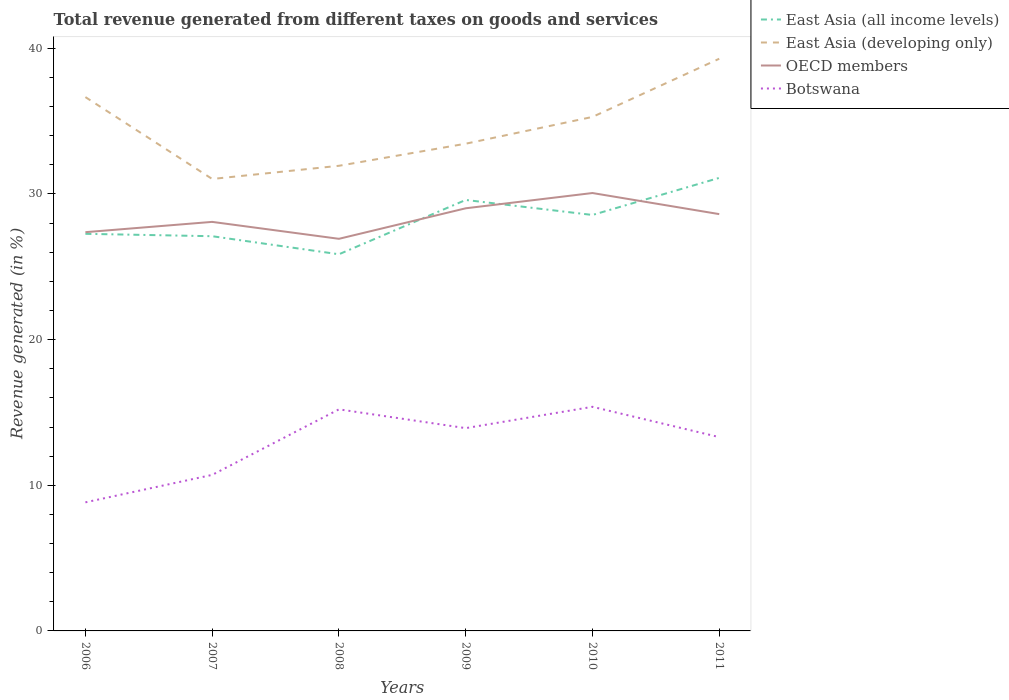How many different coloured lines are there?
Offer a terse response. 4. Is the number of lines equal to the number of legend labels?
Provide a succinct answer. Yes. Across all years, what is the maximum total revenue generated in OECD members?
Offer a terse response. 26.92. What is the total total revenue generated in East Asia (developing only) in the graph?
Ensure brevity in your answer.  -7.35. What is the difference between the highest and the second highest total revenue generated in East Asia (all income levels)?
Your answer should be compact. 5.24. What is the difference between the highest and the lowest total revenue generated in OECD members?
Your response must be concise. 3. Is the total revenue generated in OECD members strictly greater than the total revenue generated in East Asia (all income levels) over the years?
Your answer should be very brief. No. Does the graph contain any zero values?
Your answer should be compact. No. Where does the legend appear in the graph?
Ensure brevity in your answer.  Top right. How many legend labels are there?
Make the answer very short. 4. How are the legend labels stacked?
Your answer should be very brief. Vertical. What is the title of the graph?
Keep it short and to the point. Total revenue generated from different taxes on goods and services. Does "Egypt, Arab Rep." appear as one of the legend labels in the graph?
Give a very brief answer. No. What is the label or title of the X-axis?
Provide a succinct answer. Years. What is the label or title of the Y-axis?
Ensure brevity in your answer.  Revenue generated (in %). What is the Revenue generated (in %) of East Asia (all income levels) in 2006?
Make the answer very short. 27.26. What is the Revenue generated (in %) in East Asia (developing only) in 2006?
Provide a succinct answer. 36.65. What is the Revenue generated (in %) of OECD members in 2006?
Provide a succinct answer. 27.38. What is the Revenue generated (in %) of Botswana in 2006?
Keep it short and to the point. 8.83. What is the Revenue generated (in %) in East Asia (all income levels) in 2007?
Ensure brevity in your answer.  27.1. What is the Revenue generated (in %) in East Asia (developing only) in 2007?
Give a very brief answer. 31.03. What is the Revenue generated (in %) of OECD members in 2007?
Provide a succinct answer. 28.08. What is the Revenue generated (in %) of Botswana in 2007?
Your answer should be compact. 10.71. What is the Revenue generated (in %) in East Asia (all income levels) in 2008?
Your answer should be very brief. 25.86. What is the Revenue generated (in %) in East Asia (developing only) in 2008?
Offer a very short reply. 31.94. What is the Revenue generated (in %) in OECD members in 2008?
Provide a succinct answer. 26.92. What is the Revenue generated (in %) in Botswana in 2008?
Offer a very short reply. 15.21. What is the Revenue generated (in %) in East Asia (all income levels) in 2009?
Offer a very short reply. 29.59. What is the Revenue generated (in %) of East Asia (developing only) in 2009?
Offer a very short reply. 33.45. What is the Revenue generated (in %) of OECD members in 2009?
Your response must be concise. 29.02. What is the Revenue generated (in %) in Botswana in 2009?
Give a very brief answer. 13.92. What is the Revenue generated (in %) in East Asia (all income levels) in 2010?
Offer a terse response. 28.56. What is the Revenue generated (in %) in East Asia (developing only) in 2010?
Give a very brief answer. 35.29. What is the Revenue generated (in %) in OECD members in 2010?
Offer a terse response. 30.07. What is the Revenue generated (in %) in Botswana in 2010?
Your answer should be compact. 15.39. What is the Revenue generated (in %) in East Asia (all income levels) in 2011?
Provide a short and direct response. 31.11. What is the Revenue generated (in %) of East Asia (developing only) in 2011?
Offer a terse response. 39.28. What is the Revenue generated (in %) of OECD members in 2011?
Keep it short and to the point. 28.62. What is the Revenue generated (in %) in Botswana in 2011?
Make the answer very short. 13.31. Across all years, what is the maximum Revenue generated (in %) of East Asia (all income levels)?
Your response must be concise. 31.11. Across all years, what is the maximum Revenue generated (in %) of East Asia (developing only)?
Your answer should be compact. 39.28. Across all years, what is the maximum Revenue generated (in %) of OECD members?
Ensure brevity in your answer.  30.07. Across all years, what is the maximum Revenue generated (in %) of Botswana?
Offer a terse response. 15.39. Across all years, what is the minimum Revenue generated (in %) of East Asia (all income levels)?
Make the answer very short. 25.86. Across all years, what is the minimum Revenue generated (in %) in East Asia (developing only)?
Provide a short and direct response. 31.03. Across all years, what is the minimum Revenue generated (in %) of OECD members?
Your response must be concise. 26.92. Across all years, what is the minimum Revenue generated (in %) in Botswana?
Offer a terse response. 8.83. What is the total Revenue generated (in %) of East Asia (all income levels) in the graph?
Offer a terse response. 169.48. What is the total Revenue generated (in %) in East Asia (developing only) in the graph?
Keep it short and to the point. 207.65. What is the total Revenue generated (in %) of OECD members in the graph?
Make the answer very short. 170.08. What is the total Revenue generated (in %) of Botswana in the graph?
Offer a very short reply. 77.37. What is the difference between the Revenue generated (in %) of East Asia (all income levels) in 2006 and that in 2007?
Offer a very short reply. 0.16. What is the difference between the Revenue generated (in %) of East Asia (developing only) in 2006 and that in 2007?
Provide a succinct answer. 5.62. What is the difference between the Revenue generated (in %) of OECD members in 2006 and that in 2007?
Provide a succinct answer. -0.71. What is the difference between the Revenue generated (in %) of Botswana in 2006 and that in 2007?
Your answer should be compact. -1.88. What is the difference between the Revenue generated (in %) in East Asia (all income levels) in 2006 and that in 2008?
Your response must be concise. 1.4. What is the difference between the Revenue generated (in %) in East Asia (developing only) in 2006 and that in 2008?
Give a very brief answer. 4.72. What is the difference between the Revenue generated (in %) of OECD members in 2006 and that in 2008?
Keep it short and to the point. 0.46. What is the difference between the Revenue generated (in %) in Botswana in 2006 and that in 2008?
Your response must be concise. -6.38. What is the difference between the Revenue generated (in %) in East Asia (all income levels) in 2006 and that in 2009?
Make the answer very short. -2.33. What is the difference between the Revenue generated (in %) of East Asia (developing only) in 2006 and that in 2009?
Offer a terse response. 3.2. What is the difference between the Revenue generated (in %) in OECD members in 2006 and that in 2009?
Keep it short and to the point. -1.64. What is the difference between the Revenue generated (in %) in Botswana in 2006 and that in 2009?
Ensure brevity in your answer.  -5.09. What is the difference between the Revenue generated (in %) in East Asia (all income levels) in 2006 and that in 2010?
Give a very brief answer. -1.29. What is the difference between the Revenue generated (in %) in East Asia (developing only) in 2006 and that in 2010?
Your answer should be compact. 1.36. What is the difference between the Revenue generated (in %) of OECD members in 2006 and that in 2010?
Offer a very short reply. -2.69. What is the difference between the Revenue generated (in %) of Botswana in 2006 and that in 2010?
Provide a short and direct response. -6.56. What is the difference between the Revenue generated (in %) in East Asia (all income levels) in 2006 and that in 2011?
Your response must be concise. -3.84. What is the difference between the Revenue generated (in %) in East Asia (developing only) in 2006 and that in 2011?
Offer a terse response. -2.63. What is the difference between the Revenue generated (in %) in OECD members in 2006 and that in 2011?
Provide a succinct answer. -1.24. What is the difference between the Revenue generated (in %) of Botswana in 2006 and that in 2011?
Provide a succinct answer. -4.48. What is the difference between the Revenue generated (in %) in East Asia (all income levels) in 2007 and that in 2008?
Offer a very short reply. 1.24. What is the difference between the Revenue generated (in %) in East Asia (developing only) in 2007 and that in 2008?
Your answer should be very brief. -0.91. What is the difference between the Revenue generated (in %) of OECD members in 2007 and that in 2008?
Provide a succinct answer. 1.16. What is the difference between the Revenue generated (in %) of Botswana in 2007 and that in 2008?
Your answer should be compact. -4.5. What is the difference between the Revenue generated (in %) in East Asia (all income levels) in 2007 and that in 2009?
Provide a short and direct response. -2.49. What is the difference between the Revenue generated (in %) in East Asia (developing only) in 2007 and that in 2009?
Provide a short and direct response. -2.42. What is the difference between the Revenue generated (in %) of OECD members in 2007 and that in 2009?
Offer a very short reply. -0.93. What is the difference between the Revenue generated (in %) in Botswana in 2007 and that in 2009?
Ensure brevity in your answer.  -3.21. What is the difference between the Revenue generated (in %) in East Asia (all income levels) in 2007 and that in 2010?
Keep it short and to the point. -1.46. What is the difference between the Revenue generated (in %) of East Asia (developing only) in 2007 and that in 2010?
Provide a short and direct response. -4.26. What is the difference between the Revenue generated (in %) of OECD members in 2007 and that in 2010?
Give a very brief answer. -1.98. What is the difference between the Revenue generated (in %) in Botswana in 2007 and that in 2010?
Keep it short and to the point. -4.68. What is the difference between the Revenue generated (in %) in East Asia (all income levels) in 2007 and that in 2011?
Your answer should be compact. -4.01. What is the difference between the Revenue generated (in %) of East Asia (developing only) in 2007 and that in 2011?
Your answer should be compact. -8.25. What is the difference between the Revenue generated (in %) in OECD members in 2007 and that in 2011?
Offer a terse response. -0.53. What is the difference between the Revenue generated (in %) of Botswana in 2007 and that in 2011?
Keep it short and to the point. -2.59. What is the difference between the Revenue generated (in %) of East Asia (all income levels) in 2008 and that in 2009?
Keep it short and to the point. -3.73. What is the difference between the Revenue generated (in %) in East Asia (developing only) in 2008 and that in 2009?
Provide a short and direct response. -1.52. What is the difference between the Revenue generated (in %) in OECD members in 2008 and that in 2009?
Your answer should be compact. -2.1. What is the difference between the Revenue generated (in %) in Botswana in 2008 and that in 2009?
Offer a very short reply. 1.29. What is the difference between the Revenue generated (in %) in East Asia (all income levels) in 2008 and that in 2010?
Your response must be concise. -2.7. What is the difference between the Revenue generated (in %) of East Asia (developing only) in 2008 and that in 2010?
Your response must be concise. -3.35. What is the difference between the Revenue generated (in %) of OECD members in 2008 and that in 2010?
Provide a short and direct response. -3.14. What is the difference between the Revenue generated (in %) of Botswana in 2008 and that in 2010?
Offer a terse response. -0.17. What is the difference between the Revenue generated (in %) of East Asia (all income levels) in 2008 and that in 2011?
Provide a succinct answer. -5.24. What is the difference between the Revenue generated (in %) of East Asia (developing only) in 2008 and that in 2011?
Give a very brief answer. -7.35. What is the difference between the Revenue generated (in %) in OECD members in 2008 and that in 2011?
Offer a terse response. -1.7. What is the difference between the Revenue generated (in %) of Botswana in 2008 and that in 2011?
Offer a very short reply. 1.91. What is the difference between the Revenue generated (in %) of East Asia (all income levels) in 2009 and that in 2010?
Offer a terse response. 1.03. What is the difference between the Revenue generated (in %) of East Asia (developing only) in 2009 and that in 2010?
Your answer should be very brief. -1.84. What is the difference between the Revenue generated (in %) of OECD members in 2009 and that in 2010?
Provide a short and direct response. -1.05. What is the difference between the Revenue generated (in %) of Botswana in 2009 and that in 2010?
Offer a terse response. -1.46. What is the difference between the Revenue generated (in %) in East Asia (all income levels) in 2009 and that in 2011?
Give a very brief answer. -1.52. What is the difference between the Revenue generated (in %) in East Asia (developing only) in 2009 and that in 2011?
Your response must be concise. -5.83. What is the difference between the Revenue generated (in %) of OECD members in 2009 and that in 2011?
Provide a short and direct response. 0.4. What is the difference between the Revenue generated (in %) of Botswana in 2009 and that in 2011?
Ensure brevity in your answer.  0.62. What is the difference between the Revenue generated (in %) of East Asia (all income levels) in 2010 and that in 2011?
Offer a very short reply. -2.55. What is the difference between the Revenue generated (in %) of East Asia (developing only) in 2010 and that in 2011?
Offer a very short reply. -3.99. What is the difference between the Revenue generated (in %) in OECD members in 2010 and that in 2011?
Your response must be concise. 1.45. What is the difference between the Revenue generated (in %) in Botswana in 2010 and that in 2011?
Ensure brevity in your answer.  2.08. What is the difference between the Revenue generated (in %) of East Asia (all income levels) in 2006 and the Revenue generated (in %) of East Asia (developing only) in 2007?
Your answer should be very brief. -3.77. What is the difference between the Revenue generated (in %) of East Asia (all income levels) in 2006 and the Revenue generated (in %) of OECD members in 2007?
Ensure brevity in your answer.  -0.82. What is the difference between the Revenue generated (in %) of East Asia (all income levels) in 2006 and the Revenue generated (in %) of Botswana in 2007?
Give a very brief answer. 16.55. What is the difference between the Revenue generated (in %) in East Asia (developing only) in 2006 and the Revenue generated (in %) in OECD members in 2007?
Offer a very short reply. 8.57. What is the difference between the Revenue generated (in %) of East Asia (developing only) in 2006 and the Revenue generated (in %) of Botswana in 2007?
Provide a succinct answer. 25.94. What is the difference between the Revenue generated (in %) in OECD members in 2006 and the Revenue generated (in %) in Botswana in 2007?
Ensure brevity in your answer.  16.66. What is the difference between the Revenue generated (in %) of East Asia (all income levels) in 2006 and the Revenue generated (in %) of East Asia (developing only) in 2008?
Offer a very short reply. -4.67. What is the difference between the Revenue generated (in %) in East Asia (all income levels) in 2006 and the Revenue generated (in %) in OECD members in 2008?
Give a very brief answer. 0.34. What is the difference between the Revenue generated (in %) in East Asia (all income levels) in 2006 and the Revenue generated (in %) in Botswana in 2008?
Your answer should be very brief. 12.05. What is the difference between the Revenue generated (in %) in East Asia (developing only) in 2006 and the Revenue generated (in %) in OECD members in 2008?
Offer a terse response. 9.73. What is the difference between the Revenue generated (in %) in East Asia (developing only) in 2006 and the Revenue generated (in %) in Botswana in 2008?
Ensure brevity in your answer.  21.44. What is the difference between the Revenue generated (in %) in OECD members in 2006 and the Revenue generated (in %) in Botswana in 2008?
Keep it short and to the point. 12.16. What is the difference between the Revenue generated (in %) in East Asia (all income levels) in 2006 and the Revenue generated (in %) in East Asia (developing only) in 2009?
Ensure brevity in your answer.  -6.19. What is the difference between the Revenue generated (in %) in East Asia (all income levels) in 2006 and the Revenue generated (in %) in OECD members in 2009?
Make the answer very short. -1.75. What is the difference between the Revenue generated (in %) in East Asia (all income levels) in 2006 and the Revenue generated (in %) in Botswana in 2009?
Your answer should be compact. 13.34. What is the difference between the Revenue generated (in %) of East Asia (developing only) in 2006 and the Revenue generated (in %) of OECD members in 2009?
Provide a succinct answer. 7.63. What is the difference between the Revenue generated (in %) of East Asia (developing only) in 2006 and the Revenue generated (in %) of Botswana in 2009?
Ensure brevity in your answer.  22.73. What is the difference between the Revenue generated (in %) of OECD members in 2006 and the Revenue generated (in %) of Botswana in 2009?
Your answer should be very brief. 13.45. What is the difference between the Revenue generated (in %) of East Asia (all income levels) in 2006 and the Revenue generated (in %) of East Asia (developing only) in 2010?
Keep it short and to the point. -8.03. What is the difference between the Revenue generated (in %) in East Asia (all income levels) in 2006 and the Revenue generated (in %) in OECD members in 2010?
Your answer should be compact. -2.8. What is the difference between the Revenue generated (in %) of East Asia (all income levels) in 2006 and the Revenue generated (in %) of Botswana in 2010?
Offer a terse response. 11.88. What is the difference between the Revenue generated (in %) of East Asia (developing only) in 2006 and the Revenue generated (in %) of OECD members in 2010?
Make the answer very short. 6.59. What is the difference between the Revenue generated (in %) of East Asia (developing only) in 2006 and the Revenue generated (in %) of Botswana in 2010?
Provide a short and direct response. 21.26. What is the difference between the Revenue generated (in %) of OECD members in 2006 and the Revenue generated (in %) of Botswana in 2010?
Keep it short and to the point. 11.99. What is the difference between the Revenue generated (in %) of East Asia (all income levels) in 2006 and the Revenue generated (in %) of East Asia (developing only) in 2011?
Offer a terse response. -12.02. What is the difference between the Revenue generated (in %) of East Asia (all income levels) in 2006 and the Revenue generated (in %) of OECD members in 2011?
Give a very brief answer. -1.35. What is the difference between the Revenue generated (in %) in East Asia (all income levels) in 2006 and the Revenue generated (in %) in Botswana in 2011?
Your answer should be compact. 13.96. What is the difference between the Revenue generated (in %) of East Asia (developing only) in 2006 and the Revenue generated (in %) of OECD members in 2011?
Provide a succinct answer. 8.03. What is the difference between the Revenue generated (in %) in East Asia (developing only) in 2006 and the Revenue generated (in %) in Botswana in 2011?
Your response must be concise. 23.35. What is the difference between the Revenue generated (in %) in OECD members in 2006 and the Revenue generated (in %) in Botswana in 2011?
Make the answer very short. 14.07. What is the difference between the Revenue generated (in %) of East Asia (all income levels) in 2007 and the Revenue generated (in %) of East Asia (developing only) in 2008?
Provide a short and direct response. -4.84. What is the difference between the Revenue generated (in %) in East Asia (all income levels) in 2007 and the Revenue generated (in %) in OECD members in 2008?
Provide a short and direct response. 0.18. What is the difference between the Revenue generated (in %) in East Asia (all income levels) in 2007 and the Revenue generated (in %) in Botswana in 2008?
Keep it short and to the point. 11.89. What is the difference between the Revenue generated (in %) of East Asia (developing only) in 2007 and the Revenue generated (in %) of OECD members in 2008?
Offer a very short reply. 4.11. What is the difference between the Revenue generated (in %) of East Asia (developing only) in 2007 and the Revenue generated (in %) of Botswana in 2008?
Provide a short and direct response. 15.82. What is the difference between the Revenue generated (in %) of OECD members in 2007 and the Revenue generated (in %) of Botswana in 2008?
Ensure brevity in your answer.  12.87. What is the difference between the Revenue generated (in %) in East Asia (all income levels) in 2007 and the Revenue generated (in %) in East Asia (developing only) in 2009?
Offer a terse response. -6.35. What is the difference between the Revenue generated (in %) in East Asia (all income levels) in 2007 and the Revenue generated (in %) in OECD members in 2009?
Ensure brevity in your answer.  -1.92. What is the difference between the Revenue generated (in %) in East Asia (all income levels) in 2007 and the Revenue generated (in %) in Botswana in 2009?
Ensure brevity in your answer.  13.18. What is the difference between the Revenue generated (in %) of East Asia (developing only) in 2007 and the Revenue generated (in %) of OECD members in 2009?
Offer a very short reply. 2.01. What is the difference between the Revenue generated (in %) in East Asia (developing only) in 2007 and the Revenue generated (in %) in Botswana in 2009?
Ensure brevity in your answer.  17.11. What is the difference between the Revenue generated (in %) in OECD members in 2007 and the Revenue generated (in %) in Botswana in 2009?
Offer a terse response. 14.16. What is the difference between the Revenue generated (in %) in East Asia (all income levels) in 2007 and the Revenue generated (in %) in East Asia (developing only) in 2010?
Make the answer very short. -8.19. What is the difference between the Revenue generated (in %) in East Asia (all income levels) in 2007 and the Revenue generated (in %) in OECD members in 2010?
Your answer should be compact. -2.97. What is the difference between the Revenue generated (in %) of East Asia (all income levels) in 2007 and the Revenue generated (in %) of Botswana in 2010?
Your answer should be compact. 11.71. What is the difference between the Revenue generated (in %) in East Asia (developing only) in 2007 and the Revenue generated (in %) in OECD members in 2010?
Make the answer very short. 0.96. What is the difference between the Revenue generated (in %) of East Asia (developing only) in 2007 and the Revenue generated (in %) of Botswana in 2010?
Offer a terse response. 15.64. What is the difference between the Revenue generated (in %) of OECD members in 2007 and the Revenue generated (in %) of Botswana in 2010?
Make the answer very short. 12.7. What is the difference between the Revenue generated (in %) in East Asia (all income levels) in 2007 and the Revenue generated (in %) in East Asia (developing only) in 2011?
Keep it short and to the point. -12.18. What is the difference between the Revenue generated (in %) of East Asia (all income levels) in 2007 and the Revenue generated (in %) of OECD members in 2011?
Give a very brief answer. -1.52. What is the difference between the Revenue generated (in %) in East Asia (all income levels) in 2007 and the Revenue generated (in %) in Botswana in 2011?
Your response must be concise. 13.79. What is the difference between the Revenue generated (in %) in East Asia (developing only) in 2007 and the Revenue generated (in %) in OECD members in 2011?
Your answer should be compact. 2.41. What is the difference between the Revenue generated (in %) of East Asia (developing only) in 2007 and the Revenue generated (in %) of Botswana in 2011?
Ensure brevity in your answer.  17.72. What is the difference between the Revenue generated (in %) of OECD members in 2007 and the Revenue generated (in %) of Botswana in 2011?
Provide a short and direct response. 14.78. What is the difference between the Revenue generated (in %) in East Asia (all income levels) in 2008 and the Revenue generated (in %) in East Asia (developing only) in 2009?
Make the answer very short. -7.59. What is the difference between the Revenue generated (in %) of East Asia (all income levels) in 2008 and the Revenue generated (in %) of OECD members in 2009?
Provide a short and direct response. -3.16. What is the difference between the Revenue generated (in %) in East Asia (all income levels) in 2008 and the Revenue generated (in %) in Botswana in 2009?
Ensure brevity in your answer.  11.94. What is the difference between the Revenue generated (in %) in East Asia (developing only) in 2008 and the Revenue generated (in %) in OECD members in 2009?
Offer a very short reply. 2.92. What is the difference between the Revenue generated (in %) of East Asia (developing only) in 2008 and the Revenue generated (in %) of Botswana in 2009?
Give a very brief answer. 18.01. What is the difference between the Revenue generated (in %) of OECD members in 2008 and the Revenue generated (in %) of Botswana in 2009?
Give a very brief answer. 13. What is the difference between the Revenue generated (in %) in East Asia (all income levels) in 2008 and the Revenue generated (in %) in East Asia (developing only) in 2010?
Provide a short and direct response. -9.43. What is the difference between the Revenue generated (in %) in East Asia (all income levels) in 2008 and the Revenue generated (in %) in OECD members in 2010?
Ensure brevity in your answer.  -4.2. What is the difference between the Revenue generated (in %) of East Asia (all income levels) in 2008 and the Revenue generated (in %) of Botswana in 2010?
Ensure brevity in your answer.  10.47. What is the difference between the Revenue generated (in %) in East Asia (developing only) in 2008 and the Revenue generated (in %) in OECD members in 2010?
Offer a very short reply. 1.87. What is the difference between the Revenue generated (in %) in East Asia (developing only) in 2008 and the Revenue generated (in %) in Botswana in 2010?
Keep it short and to the point. 16.55. What is the difference between the Revenue generated (in %) of OECD members in 2008 and the Revenue generated (in %) of Botswana in 2010?
Provide a succinct answer. 11.53. What is the difference between the Revenue generated (in %) of East Asia (all income levels) in 2008 and the Revenue generated (in %) of East Asia (developing only) in 2011?
Give a very brief answer. -13.42. What is the difference between the Revenue generated (in %) in East Asia (all income levels) in 2008 and the Revenue generated (in %) in OECD members in 2011?
Provide a succinct answer. -2.76. What is the difference between the Revenue generated (in %) of East Asia (all income levels) in 2008 and the Revenue generated (in %) of Botswana in 2011?
Offer a very short reply. 12.55. What is the difference between the Revenue generated (in %) of East Asia (developing only) in 2008 and the Revenue generated (in %) of OECD members in 2011?
Provide a short and direct response. 3.32. What is the difference between the Revenue generated (in %) in East Asia (developing only) in 2008 and the Revenue generated (in %) in Botswana in 2011?
Provide a succinct answer. 18.63. What is the difference between the Revenue generated (in %) in OECD members in 2008 and the Revenue generated (in %) in Botswana in 2011?
Your response must be concise. 13.62. What is the difference between the Revenue generated (in %) of East Asia (all income levels) in 2009 and the Revenue generated (in %) of East Asia (developing only) in 2010?
Offer a terse response. -5.7. What is the difference between the Revenue generated (in %) of East Asia (all income levels) in 2009 and the Revenue generated (in %) of OECD members in 2010?
Keep it short and to the point. -0.48. What is the difference between the Revenue generated (in %) of East Asia (all income levels) in 2009 and the Revenue generated (in %) of Botswana in 2010?
Your response must be concise. 14.2. What is the difference between the Revenue generated (in %) of East Asia (developing only) in 2009 and the Revenue generated (in %) of OECD members in 2010?
Offer a very short reply. 3.39. What is the difference between the Revenue generated (in %) in East Asia (developing only) in 2009 and the Revenue generated (in %) in Botswana in 2010?
Make the answer very short. 18.06. What is the difference between the Revenue generated (in %) of OECD members in 2009 and the Revenue generated (in %) of Botswana in 2010?
Your response must be concise. 13.63. What is the difference between the Revenue generated (in %) in East Asia (all income levels) in 2009 and the Revenue generated (in %) in East Asia (developing only) in 2011?
Provide a succinct answer. -9.69. What is the difference between the Revenue generated (in %) in East Asia (all income levels) in 2009 and the Revenue generated (in %) in OECD members in 2011?
Make the answer very short. 0.97. What is the difference between the Revenue generated (in %) in East Asia (all income levels) in 2009 and the Revenue generated (in %) in Botswana in 2011?
Provide a succinct answer. 16.28. What is the difference between the Revenue generated (in %) in East Asia (developing only) in 2009 and the Revenue generated (in %) in OECD members in 2011?
Your answer should be very brief. 4.83. What is the difference between the Revenue generated (in %) in East Asia (developing only) in 2009 and the Revenue generated (in %) in Botswana in 2011?
Give a very brief answer. 20.15. What is the difference between the Revenue generated (in %) in OECD members in 2009 and the Revenue generated (in %) in Botswana in 2011?
Offer a very short reply. 15.71. What is the difference between the Revenue generated (in %) of East Asia (all income levels) in 2010 and the Revenue generated (in %) of East Asia (developing only) in 2011?
Offer a terse response. -10.73. What is the difference between the Revenue generated (in %) in East Asia (all income levels) in 2010 and the Revenue generated (in %) in OECD members in 2011?
Make the answer very short. -0.06. What is the difference between the Revenue generated (in %) in East Asia (all income levels) in 2010 and the Revenue generated (in %) in Botswana in 2011?
Offer a very short reply. 15.25. What is the difference between the Revenue generated (in %) in East Asia (developing only) in 2010 and the Revenue generated (in %) in OECD members in 2011?
Your answer should be compact. 6.67. What is the difference between the Revenue generated (in %) of East Asia (developing only) in 2010 and the Revenue generated (in %) of Botswana in 2011?
Give a very brief answer. 21.98. What is the difference between the Revenue generated (in %) of OECD members in 2010 and the Revenue generated (in %) of Botswana in 2011?
Offer a very short reply. 16.76. What is the average Revenue generated (in %) of East Asia (all income levels) per year?
Give a very brief answer. 28.25. What is the average Revenue generated (in %) in East Asia (developing only) per year?
Give a very brief answer. 34.61. What is the average Revenue generated (in %) in OECD members per year?
Offer a terse response. 28.35. What is the average Revenue generated (in %) of Botswana per year?
Offer a terse response. 12.9. In the year 2006, what is the difference between the Revenue generated (in %) of East Asia (all income levels) and Revenue generated (in %) of East Asia (developing only)?
Provide a succinct answer. -9.39. In the year 2006, what is the difference between the Revenue generated (in %) of East Asia (all income levels) and Revenue generated (in %) of OECD members?
Give a very brief answer. -0.11. In the year 2006, what is the difference between the Revenue generated (in %) of East Asia (all income levels) and Revenue generated (in %) of Botswana?
Offer a terse response. 18.44. In the year 2006, what is the difference between the Revenue generated (in %) in East Asia (developing only) and Revenue generated (in %) in OECD members?
Give a very brief answer. 9.27. In the year 2006, what is the difference between the Revenue generated (in %) in East Asia (developing only) and Revenue generated (in %) in Botswana?
Provide a short and direct response. 27.82. In the year 2006, what is the difference between the Revenue generated (in %) in OECD members and Revenue generated (in %) in Botswana?
Make the answer very short. 18.55. In the year 2007, what is the difference between the Revenue generated (in %) of East Asia (all income levels) and Revenue generated (in %) of East Asia (developing only)?
Offer a terse response. -3.93. In the year 2007, what is the difference between the Revenue generated (in %) of East Asia (all income levels) and Revenue generated (in %) of OECD members?
Your answer should be very brief. -0.98. In the year 2007, what is the difference between the Revenue generated (in %) of East Asia (all income levels) and Revenue generated (in %) of Botswana?
Make the answer very short. 16.39. In the year 2007, what is the difference between the Revenue generated (in %) in East Asia (developing only) and Revenue generated (in %) in OECD members?
Your answer should be very brief. 2.95. In the year 2007, what is the difference between the Revenue generated (in %) in East Asia (developing only) and Revenue generated (in %) in Botswana?
Offer a very short reply. 20.32. In the year 2007, what is the difference between the Revenue generated (in %) in OECD members and Revenue generated (in %) in Botswana?
Offer a very short reply. 17.37. In the year 2008, what is the difference between the Revenue generated (in %) in East Asia (all income levels) and Revenue generated (in %) in East Asia (developing only)?
Offer a very short reply. -6.07. In the year 2008, what is the difference between the Revenue generated (in %) of East Asia (all income levels) and Revenue generated (in %) of OECD members?
Your response must be concise. -1.06. In the year 2008, what is the difference between the Revenue generated (in %) in East Asia (all income levels) and Revenue generated (in %) in Botswana?
Provide a succinct answer. 10.65. In the year 2008, what is the difference between the Revenue generated (in %) of East Asia (developing only) and Revenue generated (in %) of OECD members?
Offer a very short reply. 5.01. In the year 2008, what is the difference between the Revenue generated (in %) in East Asia (developing only) and Revenue generated (in %) in Botswana?
Provide a short and direct response. 16.72. In the year 2008, what is the difference between the Revenue generated (in %) in OECD members and Revenue generated (in %) in Botswana?
Your answer should be very brief. 11.71. In the year 2009, what is the difference between the Revenue generated (in %) in East Asia (all income levels) and Revenue generated (in %) in East Asia (developing only)?
Offer a terse response. -3.86. In the year 2009, what is the difference between the Revenue generated (in %) of East Asia (all income levels) and Revenue generated (in %) of OECD members?
Provide a short and direct response. 0.57. In the year 2009, what is the difference between the Revenue generated (in %) of East Asia (all income levels) and Revenue generated (in %) of Botswana?
Give a very brief answer. 15.67. In the year 2009, what is the difference between the Revenue generated (in %) of East Asia (developing only) and Revenue generated (in %) of OECD members?
Provide a succinct answer. 4.43. In the year 2009, what is the difference between the Revenue generated (in %) of East Asia (developing only) and Revenue generated (in %) of Botswana?
Make the answer very short. 19.53. In the year 2009, what is the difference between the Revenue generated (in %) of OECD members and Revenue generated (in %) of Botswana?
Your answer should be compact. 15.09. In the year 2010, what is the difference between the Revenue generated (in %) of East Asia (all income levels) and Revenue generated (in %) of East Asia (developing only)?
Give a very brief answer. -6.73. In the year 2010, what is the difference between the Revenue generated (in %) in East Asia (all income levels) and Revenue generated (in %) in OECD members?
Your answer should be very brief. -1.51. In the year 2010, what is the difference between the Revenue generated (in %) in East Asia (all income levels) and Revenue generated (in %) in Botswana?
Keep it short and to the point. 13.17. In the year 2010, what is the difference between the Revenue generated (in %) in East Asia (developing only) and Revenue generated (in %) in OECD members?
Your response must be concise. 5.22. In the year 2010, what is the difference between the Revenue generated (in %) in East Asia (developing only) and Revenue generated (in %) in Botswana?
Keep it short and to the point. 19.9. In the year 2010, what is the difference between the Revenue generated (in %) in OECD members and Revenue generated (in %) in Botswana?
Your answer should be compact. 14.68. In the year 2011, what is the difference between the Revenue generated (in %) in East Asia (all income levels) and Revenue generated (in %) in East Asia (developing only)?
Provide a succinct answer. -8.18. In the year 2011, what is the difference between the Revenue generated (in %) of East Asia (all income levels) and Revenue generated (in %) of OECD members?
Your answer should be compact. 2.49. In the year 2011, what is the difference between the Revenue generated (in %) of East Asia (all income levels) and Revenue generated (in %) of Botswana?
Provide a short and direct response. 17.8. In the year 2011, what is the difference between the Revenue generated (in %) in East Asia (developing only) and Revenue generated (in %) in OECD members?
Offer a terse response. 10.67. In the year 2011, what is the difference between the Revenue generated (in %) in East Asia (developing only) and Revenue generated (in %) in Botswana?
Provide a short and direct response. 25.98. In the year 2011, what is the difference between the Revenue generated (in %) of OECD members and Revenue generated (in %) of Botswana?
Your answer should be compact. 15.31. What is the ratio of the Revenue generated (in %) of East Asia (all income levels) in 2006 to that in 2007?
Provide a short and direct response. 1.01. What is the ratio of the Revenue generated (in %) in East Asia (developing only) in 2006 to that in 2007?
Your response must be concise. 1.18. What is the ratio of the Revenue generated (in %) of OECD members in 2006 to that in 2007?
Provide a short and direct response. 0.97. What is the ratio of the Revenue generated (in %) of Botswana in 2006 to that in 2007?
Make the answer very short. 0.82. What is the ratio of the Revenue generated (in %) of East Asia (all income levels) in 2006 to that in 2008?
Give a very brief answer. 1.05. What is the ratio of the Revenue generated (in %) in East Asia (developing only) in 2006 to that in 2008?
Provide a short and direct response. 1.15. What is the ratio of the Revenue generated (in %) of OECD members in 2006 to that in 2008?
Provide a succinct answer. 1.02. What is the ratio of the Revenue generated (in %) of Botswana in 2006 to that in 2008?
Provide a succinct answer. 0.58. What is the ratio of the Revenue generated (in %) of East Asia (all income levels) in 2006 to that in 2009?
Keep it short and to the point. 0.92. What is the ratio of the Revenue generated (in %) in East Asia (developing only) in 2006 to that in 2009?
Keep it short and to the point. 1.1. What is the ratio of the Revenue generated (in %) in OECD members in 2006 to that in 2009?
Provide a succinct answer. 0.94. What is the ratio of the Revenue generated (in %) of Botswana in 2006 to that in 2009?
Your answer should be very brief. 0.63. What is the ratio of the Revenue generated (in %) of East Asia (all income levels) in 2006 to that in 2010?
Your response must be concise. 0.95. What is the ratio of the Revenue generated (in %) in East Asia (developing only) in 2006 to that in 2010?
Your answer should be compact. 1.04. What is the ratio of the Revenue generated (in %) of OECD members in 2006 to that in 2010?
Provide a short and direct response. 0.91. What is the ratio of the Revenue generated (in %) of Botswana in 2006 to that in 2010?
Provide a succinct answer. 0.57. What is the ratio of the Revenue generated (in %) of East Asia (all income levels) in 2006 to that in 2011?
Give a very brief answer. 0.88. What is the ratio of the Revenue generated (in %) of East Asia (developing only) in 2006 to that in 2011?
Your response must be concise. 0.93. What is the ratio of the Revenue generated (in %) in OECD members in 2006 to that in 2011?
Provide a succinct answer. 0.96. What is the ratio of the Revenue generated (in %) in Botswana in 2006 to that in 2011?
Keep it short and to the point. 0.66. What is the ratio of the Revenue generated (in %) of East Asia (all income levels) in 2007 to that in 2008?
Provide a short and direct response. 1.05. What is the ratio of the Revenue generated (in %) in East Asia (developing only) in 2007 to that in 2008?
Your answer should be very brief. 0.97. What is the ratio of the Revenue generated (in %) of OECD members in 2007 to that in 2008?
Offer a very short reply. 1.04. What is the ratio of the Revenue generated (in %) of Botswana in 2007 to that in 2008?
Make the answer very short. 0.7. What is the ratio of the Revenue generated (in %) of East Asia (all income levels) in 2007 to that in 2009?
Offer a very short reply. 0.92. What is the ratio of the Revenue generated (in %) in East Asia (developing only) in 2007 to that in 2009?
Keep it short and to the point. 0.93. What is the ratio of the Revenue generated (in %) of OECD members in 2007 to that in 2009?
Your response must be concise. 0.97. What is the ratio of the Revenue generated (in %) in Botswana in 2007 to that in 2009?
Provide a short and direct response. 0.77. What is the ratio of the Revenue generated (in %) in East Asia (all income levels) in 2007 to that in 2010?
Your response must be concise. 0.95. What is the ratio of the Revenue generated (in %) in East Asia (developing only) in 2007 to that in 2010?
Give a very brief answer. 0.88. What is the ratio of the Revenue generated (in %) of OECD members in 2007 to that in 2010?
Provide a short and direct response. 0.93. What is the ratio of the Revenue generated (in %) in Botswana in 2007 to that in 2010?
Give a very brief answer. 0.7. What is the ratio of the Revenue generated (in %) of East Asia (all income levels) in 2007 to that in 2011?
Your answer should be very brief. 0.87. What is the ratio of the Revenue generated (in %) in East Asia (developing only) in 2007 to that in 2011?
Your response must be concise. 0.79. What is the ratio of the Revenue generated (in %) of OECD members in 2007 to that in 2011?
Your answer should be very brief. 0.98. What is the ratio of the Revenue generated (in %) in Botswana in 2007 to that in 2011?
Ensure brevity in your answer.  0.81. What is the ratio of the Revenue generated (in %) in East Asia (all income levels) in 2008 to that in 2009?
Your answer should be very brief. 0.87. What is the ratio of the Revenue generated (in %) of East Asia (developing only) in 2008 to that in 2009?
Provide a succinct answer. 0.95. What is the ratio of the Revenue generated (in %) of OECD members in 2008 to that in 2009?
Keep it short and to the point. 0.93. What is the ratio of the Revenue generated (in %) in Botswana in 2008 to that in 2009?
Make the answer very short. 1.09. What is the ratio of the Revenue generated (in %) of East Asia (all income levels) in 2008 to that in 2010?
Offer a terse response. 0.91. What is the ratio of the Revenue generated (in %) in East Asia (developing only) in 2008 to that in 2010?
Give a very brief answer. 0.9. What is the ratio of the Revenue generated (in %) in OECD members in 2008 to that in 2010?
Offer a terse response. 0.9. What is the ratio of the Revenue generated (in %) in Botswana in 2008 to that in 2010?
Your answer should be compact. 0.99. What is the ratio of the Revenue generated (in %) in East Asia (all income levels) in 2008 to that in 2011?
Give a very brief answer. 0.83. What is the ratio of the Revenue generated (in %) of East Asia (developing only) in 2008 to that in 2011?
Provide a short and direct response. 0.81. What is the ratio of the Revenue generated (in %) in OECD members in 2008 to that in 2011?
Your response must be concise. 0.94. What is the ratio of the Revenue generated (in %) of Botswana in 2008 to that in 2011?
Your answer should be very brief. 1.14. What is the ratio of the Revenue generated (in %) in East Asia (all income levels) in 2009 to that in 2010?
Offer a very short reply. 1.04. What is the ratio of the Revenue generated (in %) in East Asia (developing only) in 2009 to that in 2010?
Provide a succinct answer. 0.95. What is the ratio of the Revenue generated (in %) in OECD members in 2009 to that in 2010?
Provide a succinct answer. 0.97. What is the ratio of the Revenue generated (in %) of Botswana in 2009 to that in 2010?
Ensure brevity in your answer.  0.9. What is the ratio of the Revenue generated (in %) of East Asia (all income levels) in 2009 to that in 2011?
Keep it short and to the point. 0.95. What is the ratio of the Revenue generated (in %) in East Asia (developing only) in 2009 to that in 2011?
Offer a very short reply. 0.85. What is the ratio of the Revenue generated (in %) in Botswana in 2009 to that in 2011?
Provide a succinct answer. 1.05. What is the ratio of the Revenue generated (in %) of East Asia (all income levels) in 2010 to that in 2011?
Your answer should be very brief. 0.92. What is the ratio of the Revenue generated (in %) in East Asia (developing only) in 2010 to that in 2011?
Ensure brevity in your answer.  0.9. What is the ratio of the Revenue generated (in %) in OECD members in 2010 to that in 2011?
Keep it short and to the point. 1.05. What is the ratio of the Revenue generated (in %) in Botswana in 2010 to that in 2011?
Offer a terse response. 1.16. What is the difference between the highest and the second highest Revenue generated (in %) of East Asia (all income levels)?
Your answer should be compact. 1.52. What is the difference between the highest and the second highest Revenue generated (in %) of East Asia (developing only)?
Offer a terse response. 2.63. What is the difference between the highest and the second highest Revenue generated (in %) of OECD members?
Ensure brevity in your answer.  1.05. What is the difference between the highest and the second highest Revenue generated (in %) of Botswana?
Provide a succinct answer. 0.17. What is the difference between the highest and the lowest Revenue generated (in %) of East Asia (all income levels)?
Offer a terse response. 5.24. What is the difference between the highest and the lowest Revenue generated (in %) in East Asia (developing only)?
Make the answer very short. 8.25. What is the difference between the highest and the lowest Revenue generated (in %) of OECD members?
Offer a very short reply. 3.14. What is the difference between the highest and the lowest Revenue generated (in %) in Botswana?
Your answer should be very brief. 6.56. 